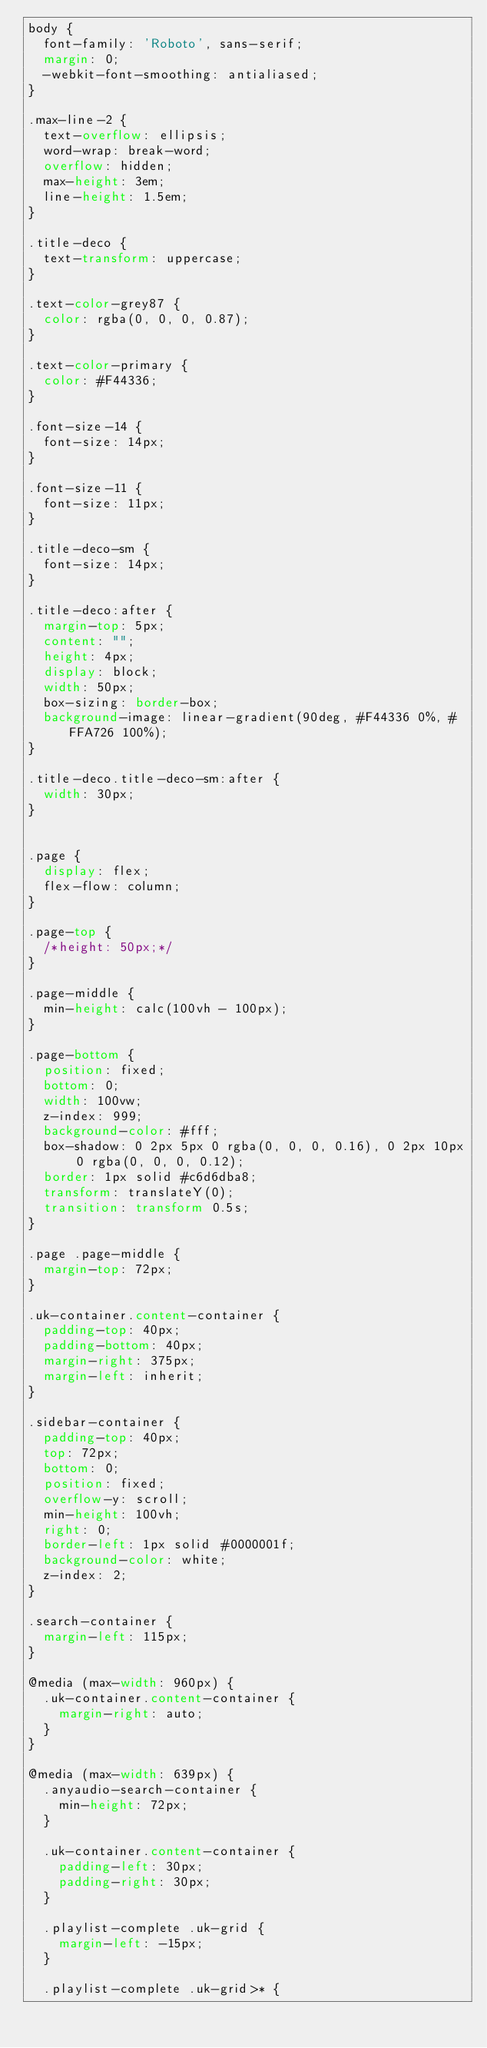Convert code to text. <code><loc_0><loc_0><loc_500><loc_500><_CSS_>body {
  font-family: 'Roboto', sans-serif;
  margin: 0;
  -webkit-font-smoothing: antialiased;
}

.max-line-2 {
  text-overflow: ellipsis;
  word-wrap: break-word;
  overflow: hidden;
  max-height: 3em;
  line-height: 1.5em;
}

.title-deco {
  text-transform: uppercase;
}

.text-color-grey87 {
  color: rgba(0, 0, 0, 0.87);
}

.text-color-primary {
  color: #F44336;
}

.font-size-14 {
  font-size: 14px;
}

.font-size-11 {
  font-size: 11px;
}

.title-deco-sm {
  font-size: 14px;
}

.title-deco:after {
  margin-top: 5px;
  content: "";
  height: 4px;
  display: block;
  width: 50px;
  box-sizing: border-box;
  background-image: linear-gradient(90deg, #F44336 0%, #FFA726 100%);
}

.title-deco.title-deco-sm:after {
  width: 30px;
}


.page {
  display: flex;
  flex-flow: column;
}

.page-top {
  /*height: 50px;*/
}

.page-middle {
  min-height: calc(100vh - 100px);
}

.page-bottom {
  position: fixed;
  bottom: 0;
  width: 100vw;
  z-index: 999;
  background-color: #fff;
  box-shadow: 0 2px 5px 0 rgba(0, 0, 0, 0.16), 0 2px 10px 0 rgba(0, 0, 0, 0.12);
  border: 1px solid #c6d6dba8;
  transform: translateY(0);
  transition: transform 0.5s;
}

.page .page-middle {
  margin-top: 72px;
}

.uk-container.content-container {
  padding-top: 40px;
  padding-bottom: 40px;
  margin-right: 375px;
  margin-left: inherit;
}

.sidebar-container {
  padding-top: 40px;
  top: 72px;
  bottom: 0;
  position: fixed;
  overflow-y: scroll;
  min-height: 100vh;
  right: 0;
  border-left: 1px solid #0000001f;
  background-color: white;
  z-index: 2;
}

.search-container {
  margin-left: 115px;
}

@media (max-width: 960px) {
  .uk-container.content-container {
    margin-right: auto;
  }
}

@media (max-width: 639px) {
  .anyaudio-search-container {
    min-height: 72px;
  }

  .uk-container.content-container {
    padding-left: 30px;
    padding-right: 30px;
  }

  .playlist-complete .uk-grid {
    margin-left: -15px;
  }

  .playlist-complete .uk-grid>* {</code> 